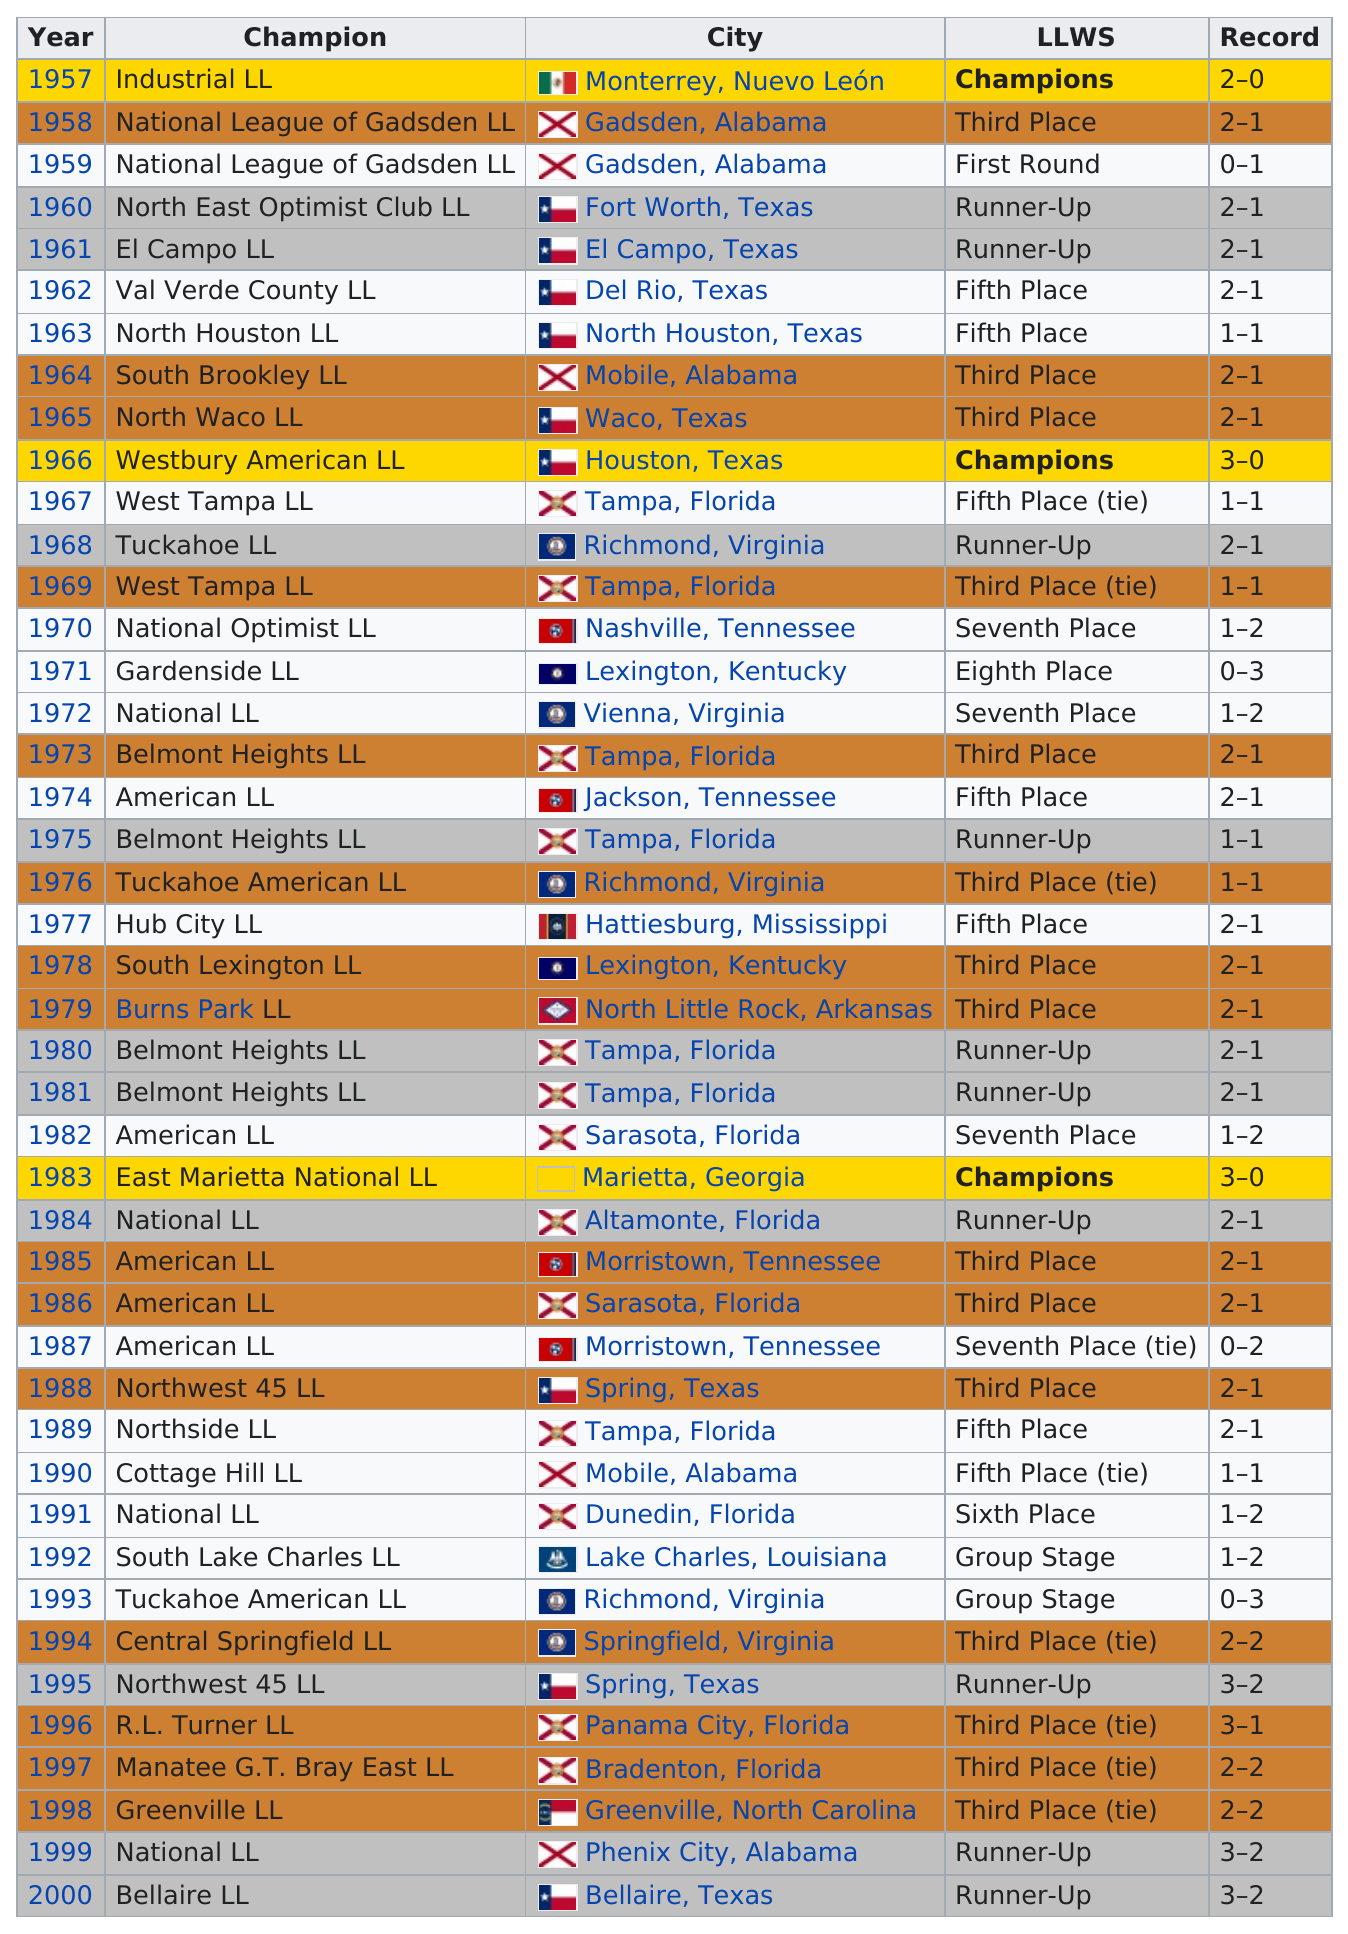List a handful of essential elements in this visual. Gardenside LLC is located in Lexington, Kentucky. In 1966, the champions had a 3-0 record before 1983. In the year 1971, the eighth-place team had no wins. The winners of the 1962 event were from Del Rio, Texas. The champions in 1961 were El Campo LL. 